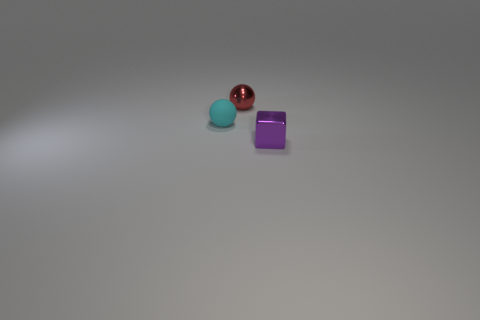Add 1 tiny purple objects. How many objects exist? 4 Subtract all blocks. How many objects are left? 2 Subtract 0 brown cylinders. How many objects are left? 3 Subtract all red shiny balls. Subtract all small cyan matte balls. How many objects are left? 1 Add 2 tiny things. How many tiny things are left? 5 Add 2 big cylinders. How many big cylinders exist? 2 